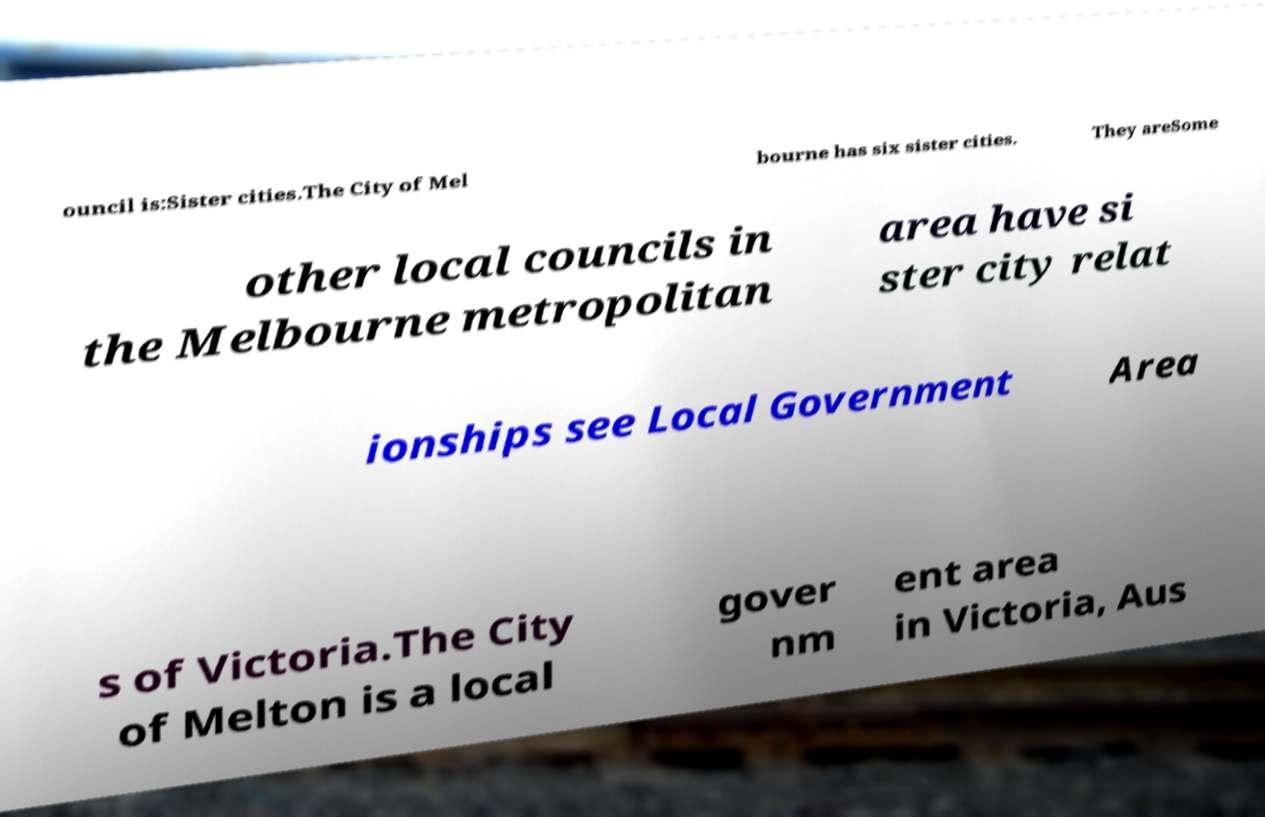There's text embedded in this image that I need extracted. Can you transcribe it verbatim? ouncil is:Sister cities.The City of Mel bourne has six sister cities. They areSome other local councils in the Melbourne metropolitan area have si ster city relat ionships see Local Government Area s of Victoria.The City of Melton is a local gover nm ent area in Victoria, Aus 